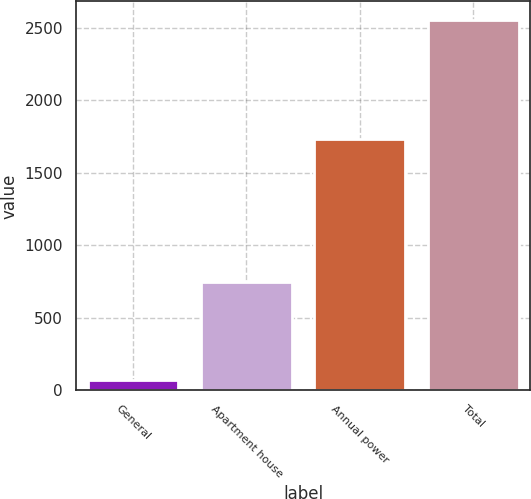Convert chart to OTSL. <chart><loc_0><loc_0><loc_500><loc_500><bar_chart><fcel>General<fcel>Apartment house<fcel>Annual power<fcel>Total<nl><fcel>74<fcel>745<fcel>1735<fcel>2554<nl></chart> 